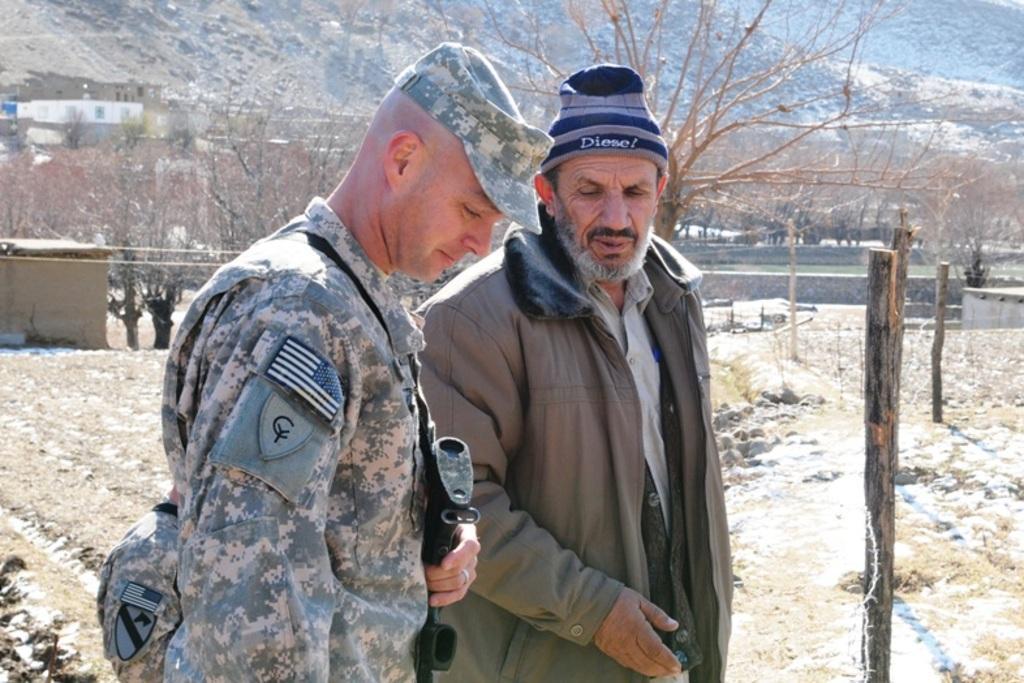Can you describe this image briefly? In this picture we can see two persons. There are wooden sticks, trees, buildings, and wall. 